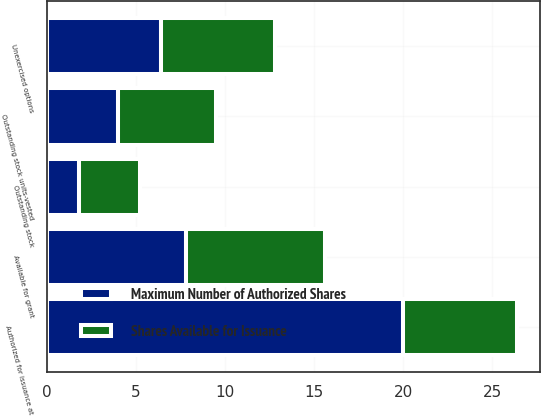Convert chart. <chart><loc_0><loc_0><loc_500><loc_500><stacked_bar_chart><ecel><fcel>Unexercised options<fcel>Outstanding stock units-vested<fcel>Outstanding stock<fcel>Available for grant<fcel>Authorized for issuance at<nl><fcel>Maximum Number of Authorized Shares<fcel>6.4<fcel>4<fcel>1.8<fcel>7.8<fcel>20<nl><fcel>Shares Available for Issuance<fcel>6.4<fcel>5.5<fcel>3.4<fcel>7.8<fcel>6.4<nl></chart> 